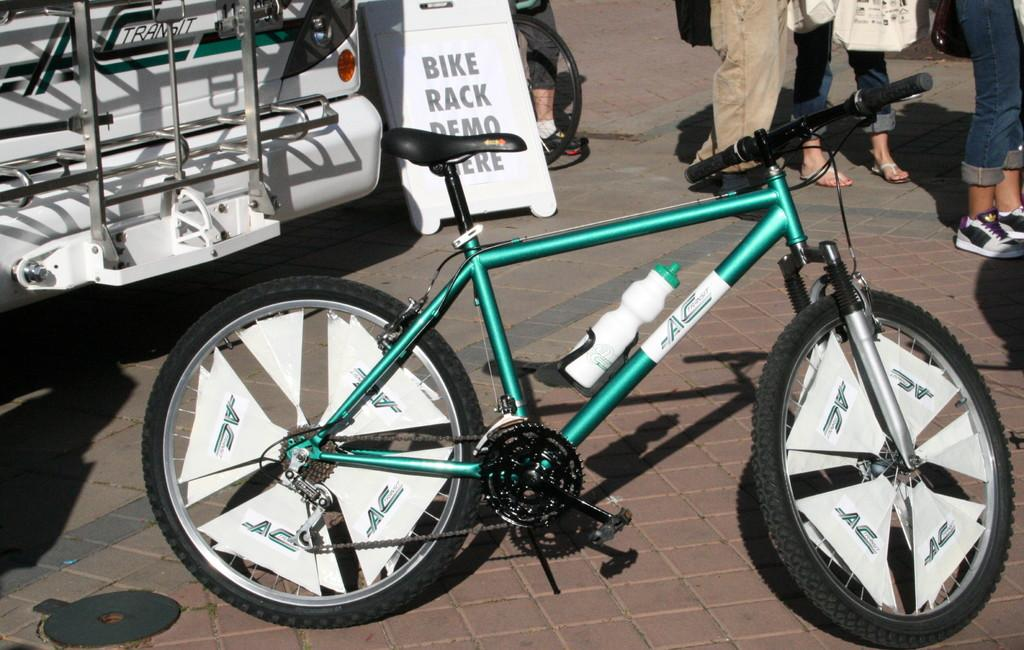What is the main object in the foreground of the image? There is a bicycle in the foreground of the image. What other object can be seen in the image? There is a bottle in the image. What can be seen in the background of the image? There is a vehicle and a board in the background of the image. Are there any people present in the image? Yes, there are people in the image. What type of ground surface is visible in the image? The ground has tiles in the image. How many legs does the country have in the image? There is no country present in the image, so it does not have any legs. 